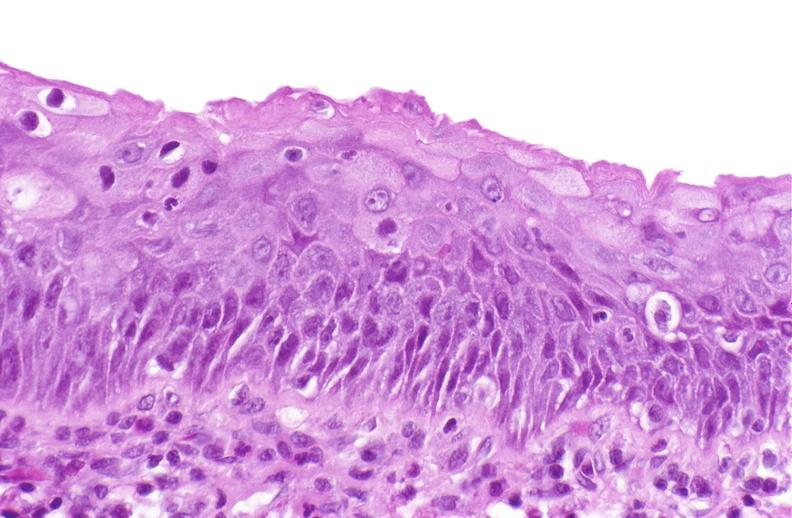why does this image show squamous metaplasia, renal pelvis?
Answer the question using a single word or phrase. Due to nephrolithiasis 